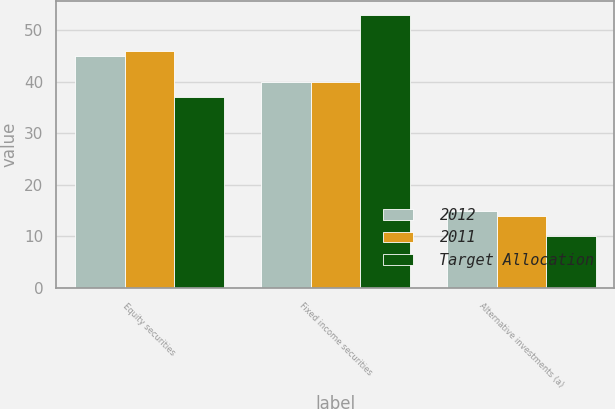<chart> <loc_0><loc_0><loc_500><loc_500><stacked_bar_chart><ecel><fcel>Equity securities<fcel>Fixed income securities<fcel>Alternative investments (a)<nl><fcel>2012<fcel>45<fcel>40<fcel>15<nl><fcel>2011<fcel>46<fcel>40<fcel>14<nl><fcel>Target Allocation<fcel>37<fcel>53<fcel>10<nl></chart> 